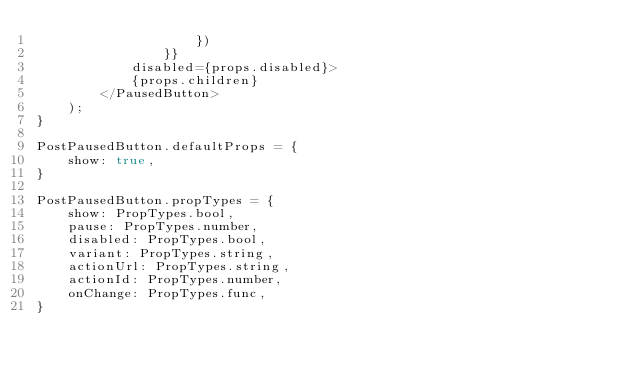Convert code to text. <code><loc_0><loc_0><loc_500><loc_500><_JavaScript_>                    })
                }}
            disabled={props.disabled}>
            {props.children}
        </PausedButton>
    );
}

PostPausedButton.defaultProps = {
    show: true,
}

PostPausedButton.propTypes = {
    show: PropTypes.bool,
    pause: PropTypes.number,
    disabled: PropTypes.bool,
    variant: PropTypes.string,
    actionUrl: PropTypes.string,
    actionId: PropTypes.number,
    onChange: PropTypes.func,
}
</code> 